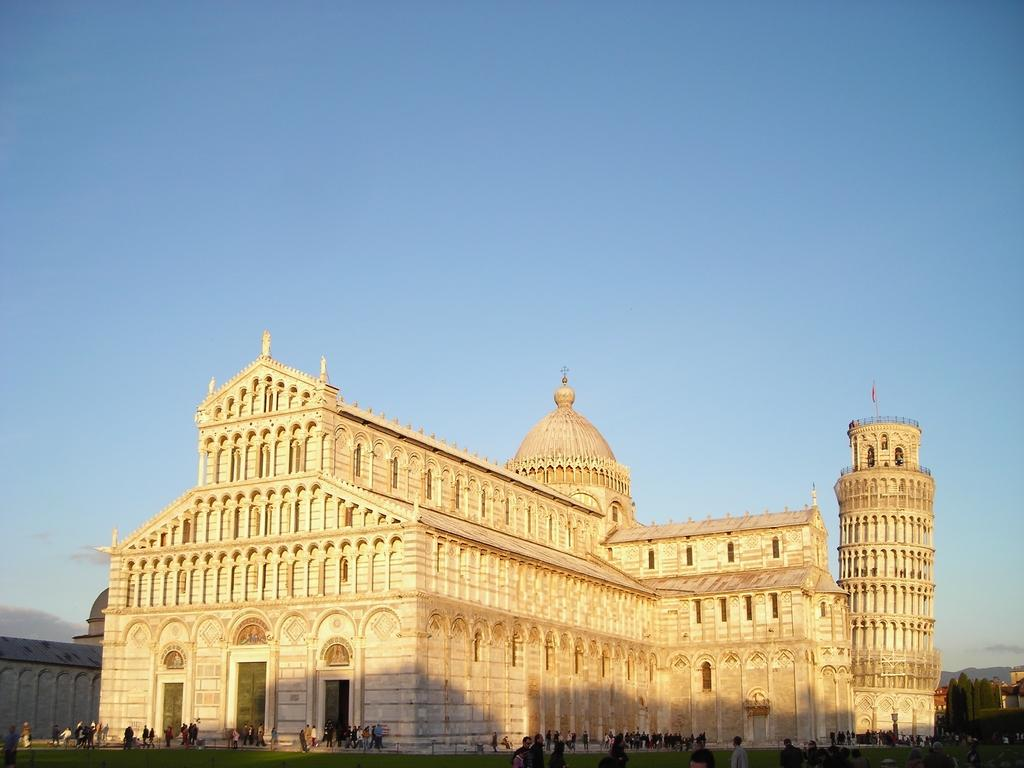What type of structures are present in the image? There are buildings in the image. Can you describe the people at the bottom of the image? There are people at the bottom of the image. What can be seen in the background of the image? The sky is visible in the background of the image. What type of shoes are the people wearing in the image? There is no information about shoes in the image, as the focus is on the buildings and the presence of people. 